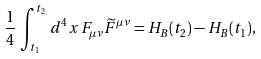Convert formula to latex. <formula><loc_0><loc_0><loc_500><loc_500>\frac { 1 } { 4 } \, \int _ { t _ { 1 } } ^ { t _ { 2 } } \, d ^ { 4 } x \, F _ { \mu \nu } \widetilde { F } ^ { \mu \nu } = H _ { B } ( t _ { 2 } ) - H _ { B } ( t _ { 1 } ) ,</formula> 